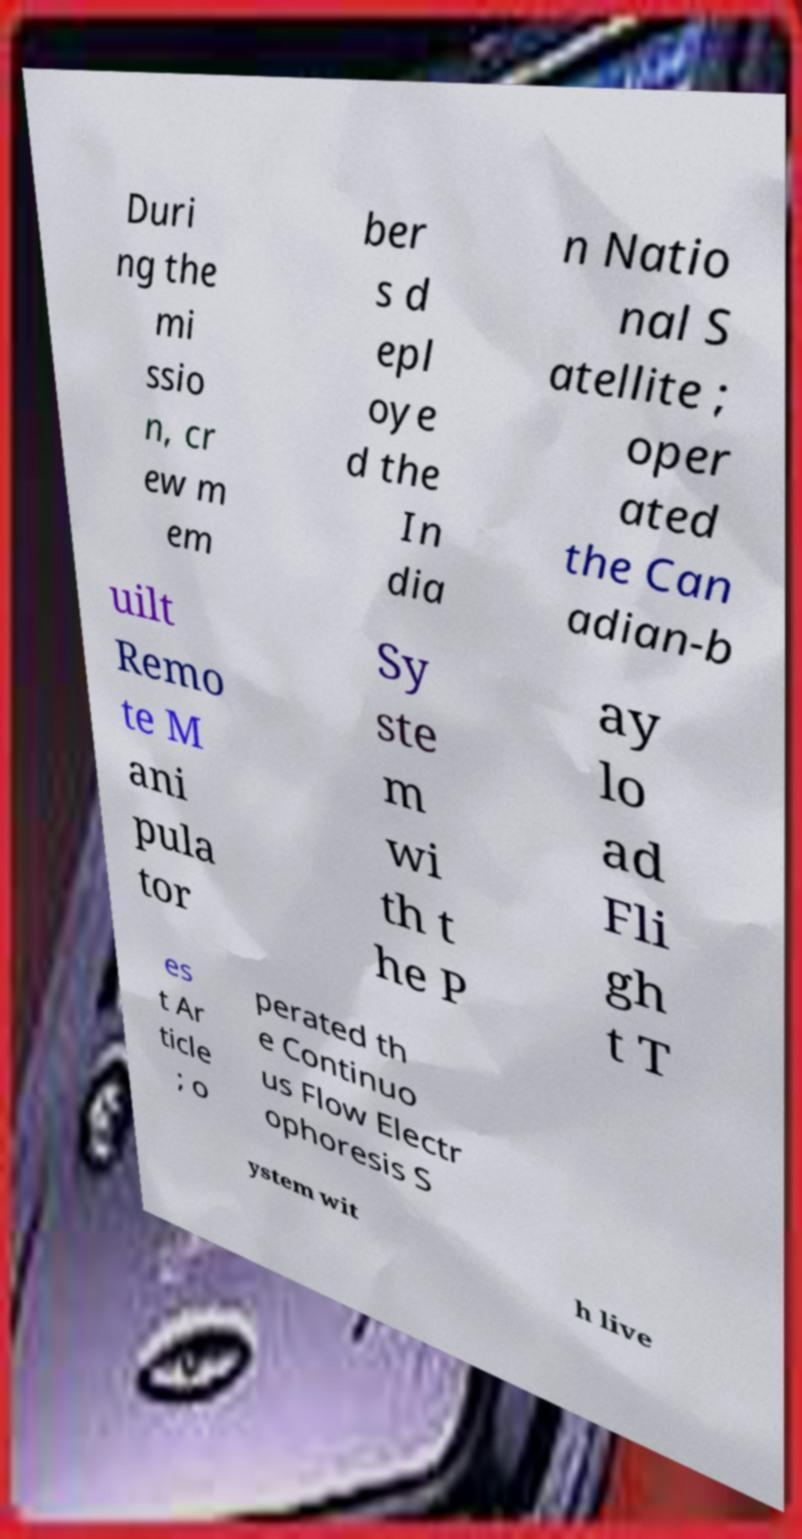Could you extract and type out the text from this image? Duri ng the mi ssio n, cr ew m em ber s d epl oye d the In dia n Natio nal S atellite ; oper ated the Can adian-b uilt Remo te M ani pula tor Sy ste m wi th t he P ay lo ad Fli gh t T es t Ar ticle ; o perated th e Continuo us Flow Electr ophoresis S ystem wit h live 